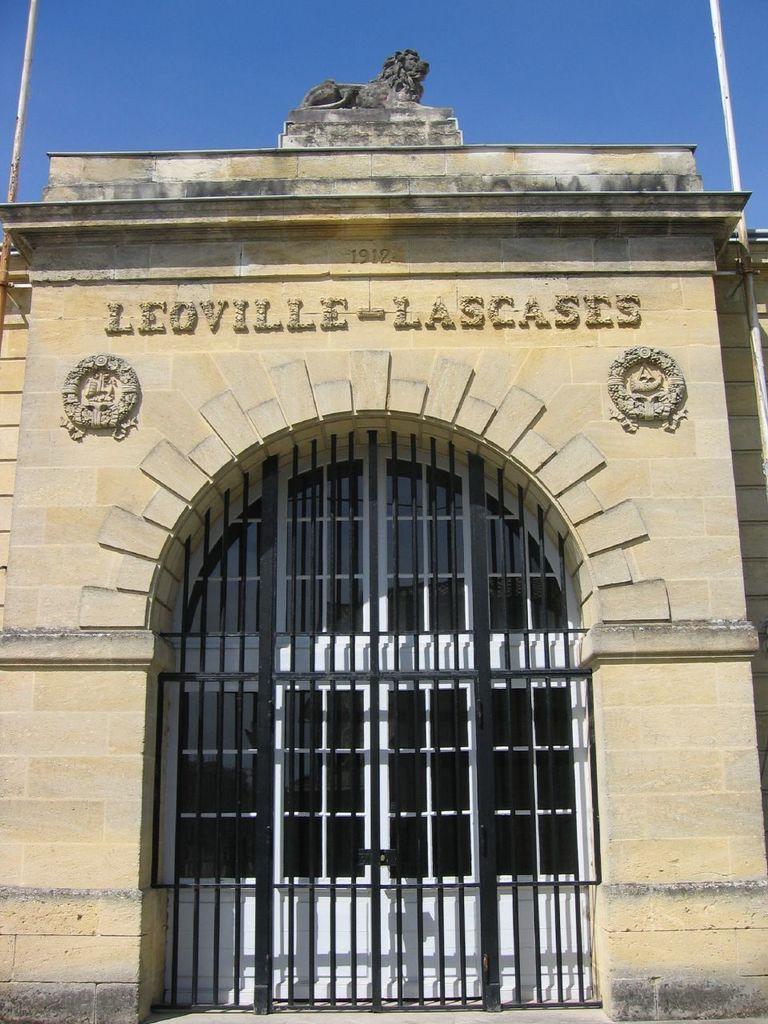How would you summarize this image in a sentence or two? In this image there is a building and we can see a gate. In the background there is sky. 